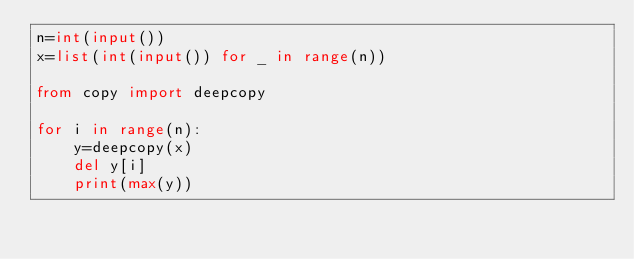Convert code to text. <code><loc_0><loc_0><loc_500><loc_500><_Python_>n=int(input())
x=list(int(input()) for _ in range(n))

from copy import deepcopy

for i in range(n):
	y=deepcopy(x)
	del y[i]
	print(max(y))</code> 